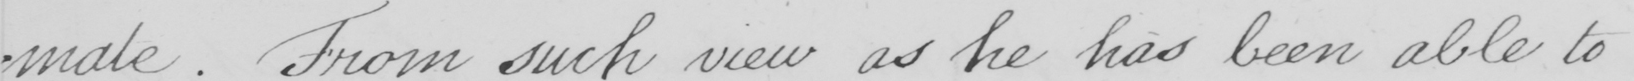Please transcribe the handwritten text in this image. -mate . From such view as he has been able to 